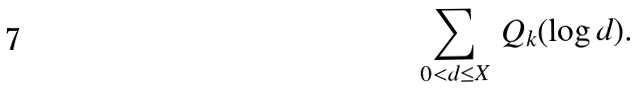<formula> <loc_0><loc_0><loc_500><loc_500>\sum _ { 0 < d \leq X } \, Q _ { k } ( \log { d } ) .</formula> 